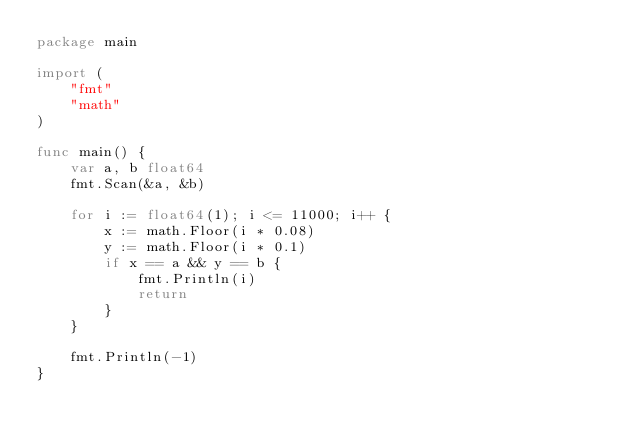Convert code to text. <code><loc_0><loc_0><loc_500><loc_500><_Go_>package main

import (
	"fmt"
	"math"
)

func main() {
	var a, b float64
	fmt.Scan(&a, &b)

	for i := float64(1); i <= 11000; i++ {
		x := math.Floor(i * 0.08)
		y := math.Floor(i * 0.1)
		if x == a && y == b {
			fmt.Println(i)
			return
		}
	}

	fmt.Println(-1)
}
</code> 